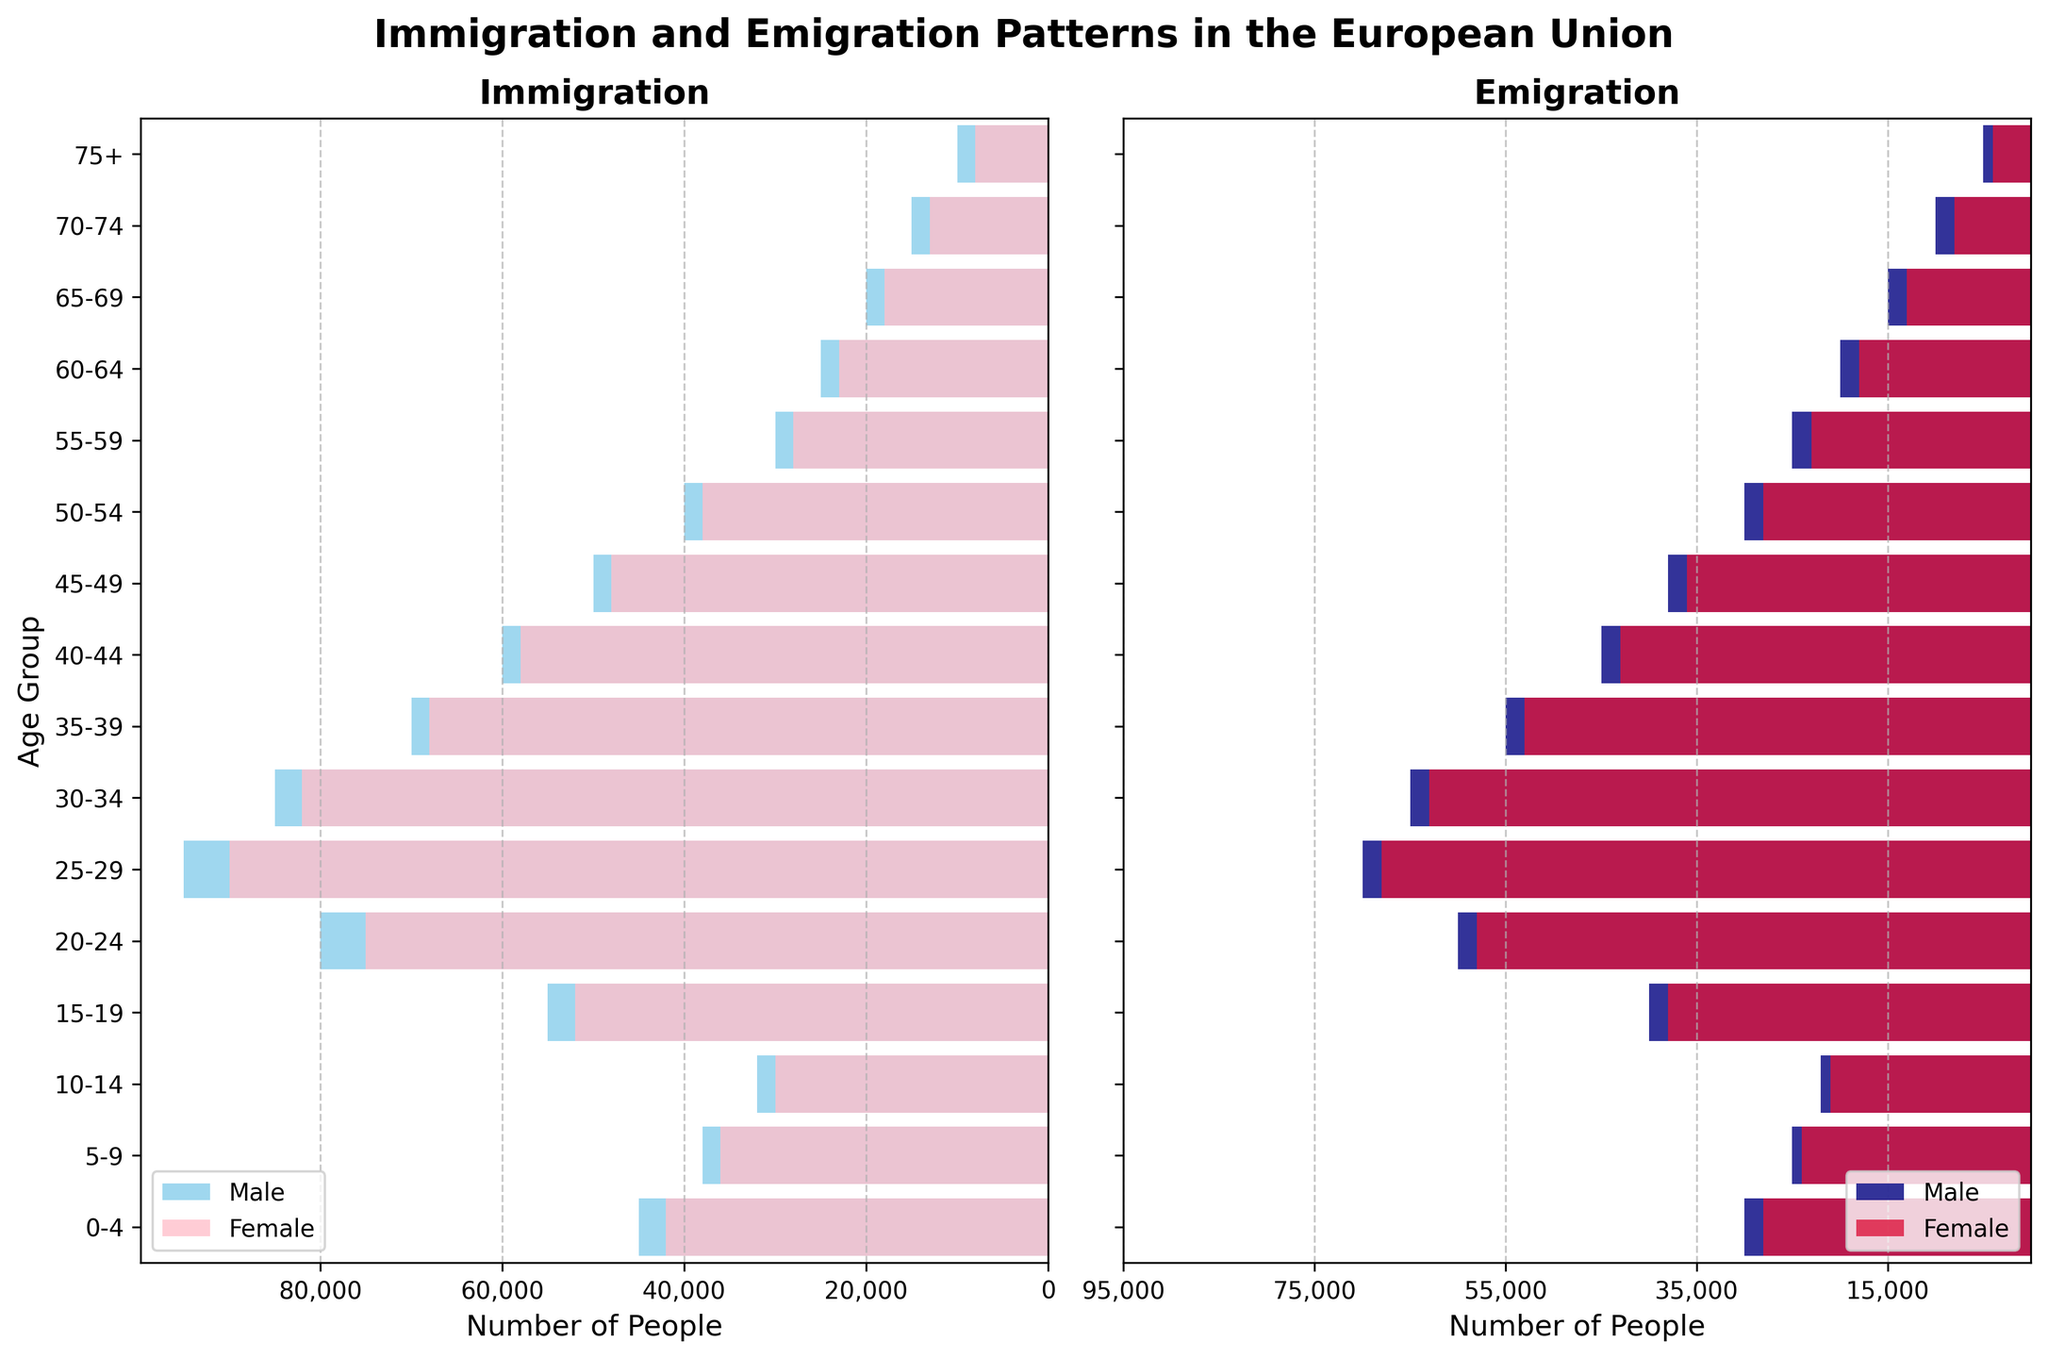What's the title of the figure? The title is typically found at the top of the figure. In this case, it reads "Immigration and Emigration Patterns in the European Union".
Answer: Immigration and Emigration Patterns in the European Union How many age groups are represented in the figure? Each bar in the horizontal bar chart represents an age group. Counting these bars, we find there are 16 age groups in total.
Answer: 16 Which age group has the highest male immigration? Look at the "Immigration" chart and compare the lengths of the skyblue bars for each age group. The 25-29 age group has the longest bar.
Answer: 25-29 What is the female emigration count for the 75+ age group? In the "Emigration" chart, the crimson bar for the 75+ age group extends to -4,000 on the x-axis. Since it is negative, the count is 4,000.
Answer: 4,000 Which gender has a higher immigration count in the 20-24 age group? Compare the skyblue (male) and pink (female) bars for the 20-24 age group in the "Immigration" chart. The male bar (80,000) extends further than the female bar (75,000).
Answer: Male What is the difference between male immigration and emigration in the 30-34 age group? Find the male immigration (85,000) in the "Immigration" chart and male emigration (-65,000) in the "Emigration" chart. Difference = 85,000 - (-65,000) = 150,000.
Answer: 150,000 Which age group has the lowest female emigration? Look at the crimson bars in the "Emigration" chart and find the age group with the smallest absolute value. The 75+ group has the shortest bar (4,000).
Answer: 75+ What's the combined total immigration count (both genders) for the 45-49 age group? In the Immigration chart, add the lengths of the skyblue (50,000) and pink (48,000) bars for the 45-49 age group. The sum is 50,000 + 48,000 = 98,000.
Answer: 98,000 Which gender has a higher emigration count in the 40-44 age group? Compare the navy (male) and crimson (female) bars for the 40-44 age group in the "Emigration" chart. The male bar (-45,000) extends further than the female bar (-43,000).
Answer: Male Is there an age group where female immigration exceeds male immigration? Scan the "Immigration" chart and compare the skyblue and pink bars for each age group. None of the pink bars extend beyond their corresponding skyblue bars, indicating there is no such age group.
Answer: No 